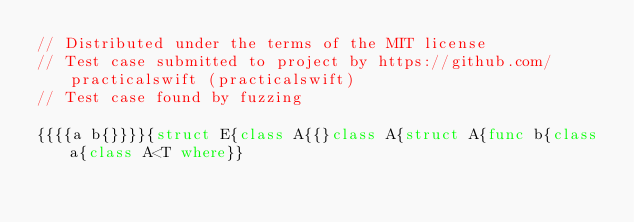Convert code to text. <code><loc_0><loc_0><loc_500><loc_500><_Swift_>// Distributed under the terms of the MIT license
// Test case submitted to project by https://github.com/practicalswift (practicalswift)
// Test case found by fuzzing

{{{{a b{}}}}{struct E{class A{{}class A{struct A{func b{class a{class A<T where}}
</code> 